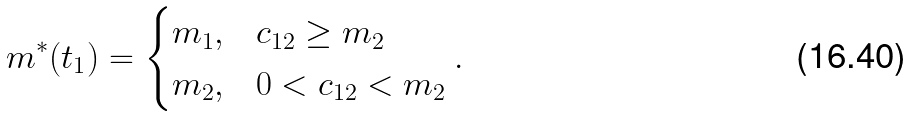Convert formula to latex. <formula><loc_0><loc_0><loc_500><loc_500>m ^ { * } ( t _ { 1 } ) = \begin{cases} m _ { 1 } , & c _ { 1 2 } \geq m _ { 2 } \\ m _ { 2 } , & 0 < c _ { 1 2 } < m _ { 2 } \end{cases} .</formula> 